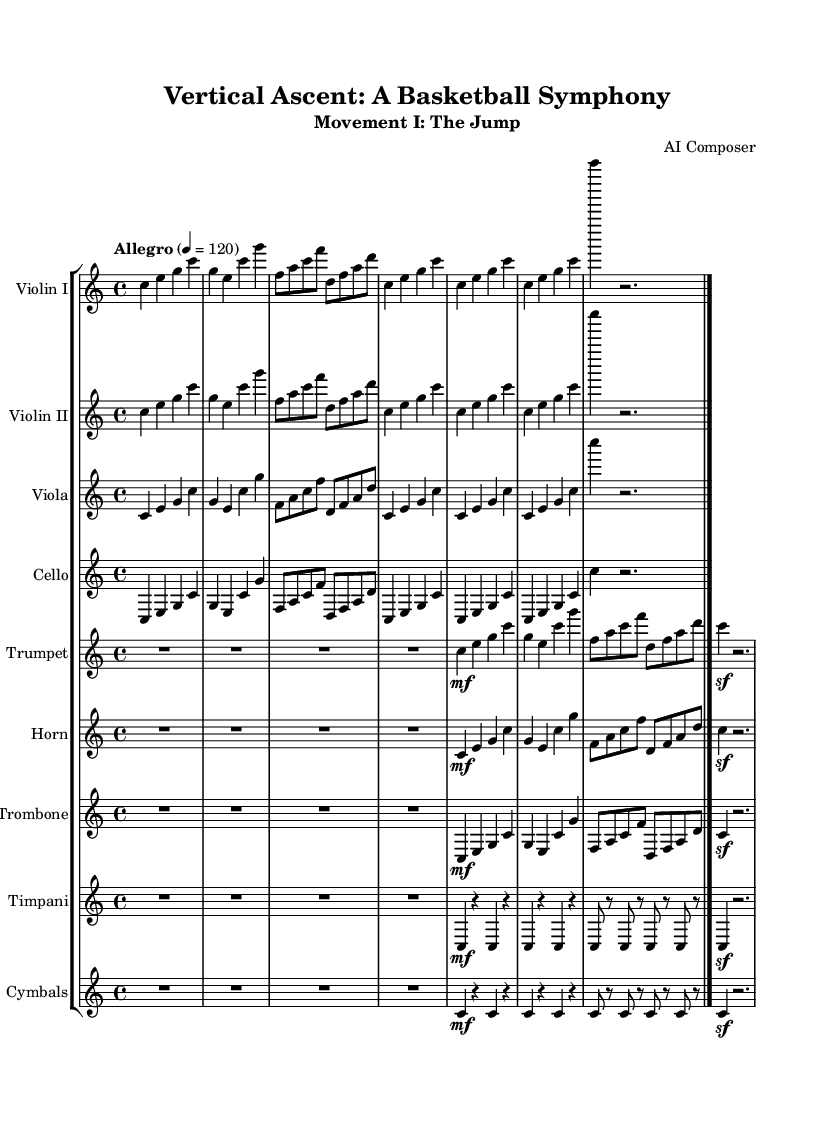What is the key signature of this music? The key signature is indicated at the beginning of the score and shows no sharps or flats, which corresponds to C major.
Answer: C major What is the time signature of this music? The time signature is shown at the beginning of the score, indicating that there are four beats per measure.
Answer: 4/4 What is the tempo marking for this piece? The tempo marking is written above the staff, stating "Allegro" with a dotted quarter note equals 120 BPM, which describes the speed of the music.
Answer: Allegro How many measures are in the violin one part? By counting the measures indicated in the violin one part from the start to the end, there are a total of seven measures, including those with repeated sections.
Answer: 7 Which instruments play the same musical line in the first section? Observing the parts marked, the first section shows that Violin I, Violin II, Viola, Cello, Trumpet, Horn, and Trombone all share the same melodic line initially.
Answer: Violin I, Violin II, Viola, Cello, Trumpet, Horn, Trombone What is the dynamic marking for the trumpet in the second measure? The dynamic marking for the trumpet is indicated with the symbol "mf," which stands for mezzo-forte, meaning moderately loud.
Answer: mf What is the role of the timpani in this symphony? The timpani provides rhythmic emphasis and punctuates important moments in the progression, typically playing strong beats and enhancing the dramatic effect.
Answer: Rhythmic emphasis 